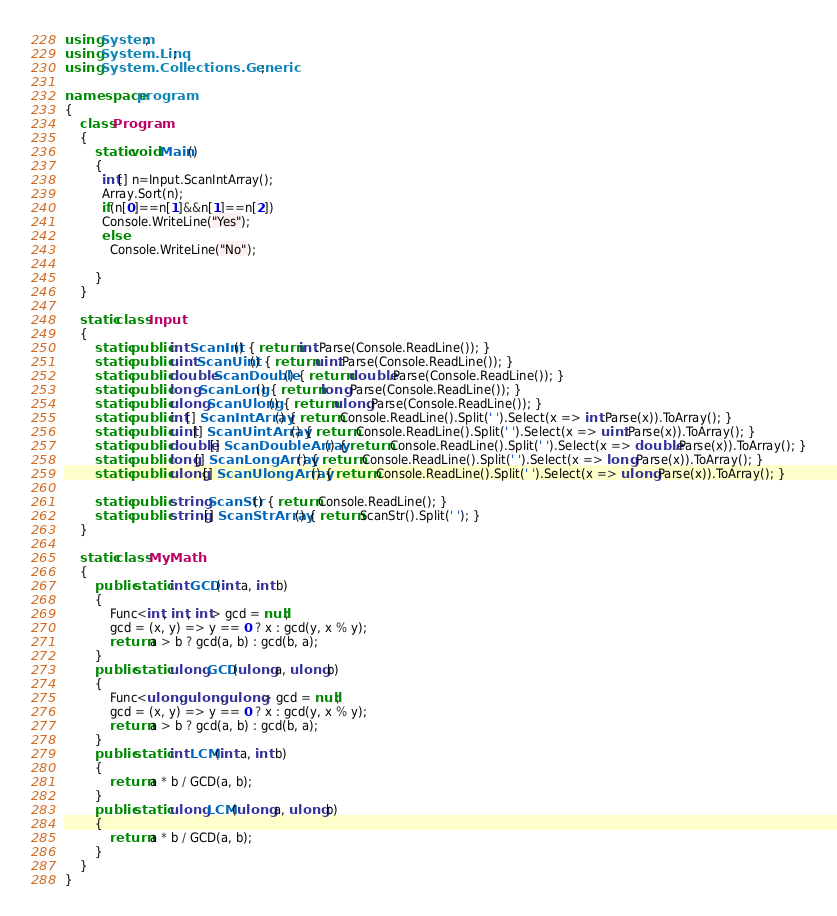Convert code to text. <code><loc_0><loc_0><loc_500><loc_500><_C#_>using System;
using System.Linq;
using System.Collections.Generic;

namespace program
{
    class Program
    {
        static void Main()
        {
          int[] n=Input.ScanIntArray();
          Array.Sort(n);
          if(n[0]==n[1]&&n[1]==n[2])
          Console.WriteLine("Yes");
          else
            Console.WriteLine("No");
          
        }
    }

    static class Input
    {
        static public int ScanInt() { return int.Parse(Console.ReadLine()); }
        static public uint ScanUint() { return uint.Parse(Console.ReadLine()); }
        static public double ScanDouble() { return double.Parse(Console.ReadLine()); }
        static public long ScanLong() { return long.Parse(Console.ReadLine()); }
        static public ulong ScanUlong() { return ulong.Parse(Console.ReadLine()); }
        static public int[] ScanIntArray() { return Console.ReadLine().Split(' ').Select(x => int.Parse(x)).ToArray(); }
        static public uint[] ScanUintArray() { return Console.ReadLine().Split(' ').Select(x => uint.Parse(x)).ToArray(); }
        static public double[] ScanDoubleArray() { return Console.ReadLine().Split(' ').Select(x => double.Parse(x)).ToArray(); }
        static public long[] ScanLongArray() { return Console.ReadLine().Split(' ').Select(x => long.Parse(x)).ToArray(); }
        static public ulong[] ScanUlongArray() { return Console.ReadLine().Split(' ').Select(x => ulong.Parse(x)).ToArray(); }

        static public string ScanStr() { return Console.ReadLine(); }
        static public string[] ScanStrArray() { return ScanStr().Split(' '); }
    }

    static class MyMath
    {
        public static int GCD(int a, int b)
        {
            Func<int, int, int> gcd = null;
            gcd = (x, y) => y == 0 ? x : gcd(y, x % y);
            return a > b ? gcd(a, b) : gcd(b, a);
        }
        public static ulong GCD(ulong a, ulong b)
        {
            Func<ulong, ulong, ulong> gcd = null;
            gcd = (x, y) => y == 0 ? x : gcd(y, x % y);
            return a > b ? gcd(a, b) : gcd(b, a);
        }
        public static int LCM(int a, int b)
        {
            return a * b / GCD(a, b);
        }
        public static ulong LCM(ulong a, ulong b)
        {
            return a * b / GCD(a, b);
        }
    }
}
</code> 